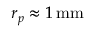Convert formula to latex. <formula><loc_0><loc_0><loc_500><loc_500>r _ { p } \approx 1 \, m m</formula> 